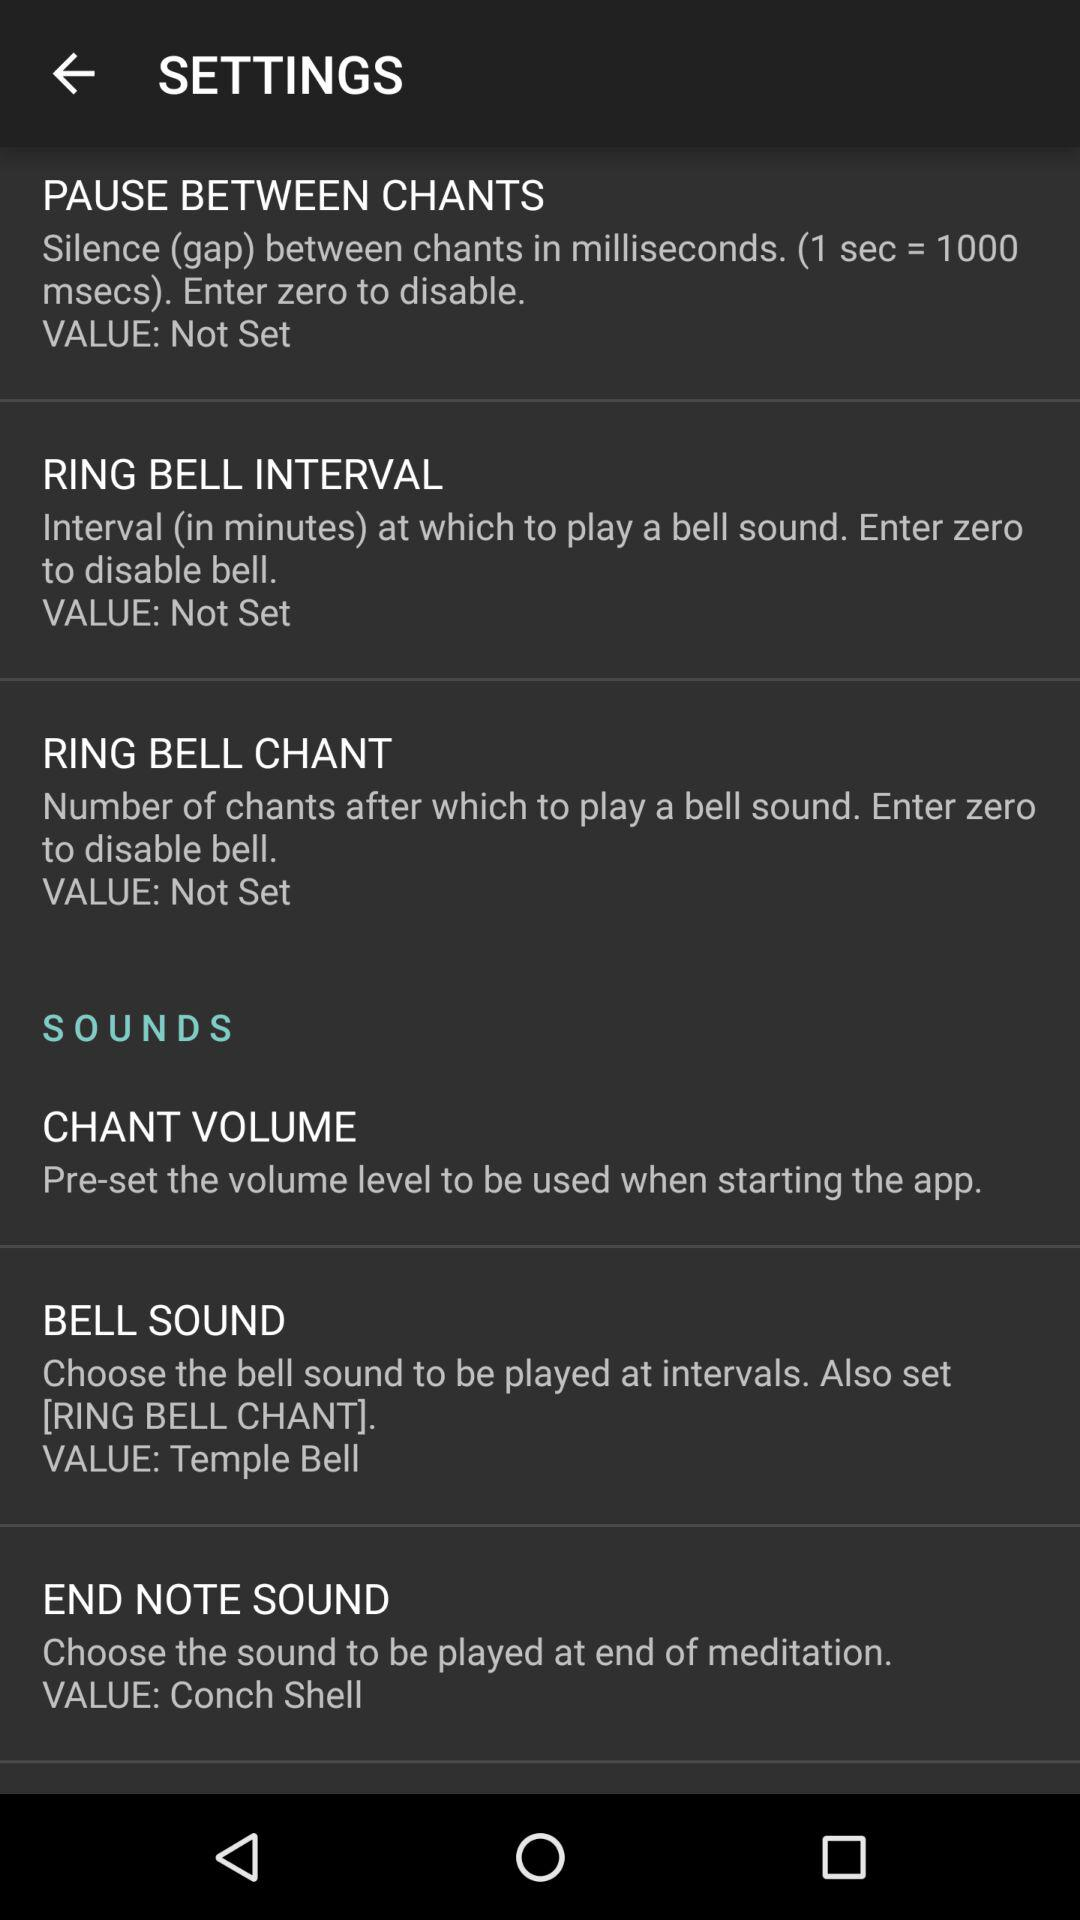What is the value set for the bell sound? The value set for the bell sound is "Temple Bell". 